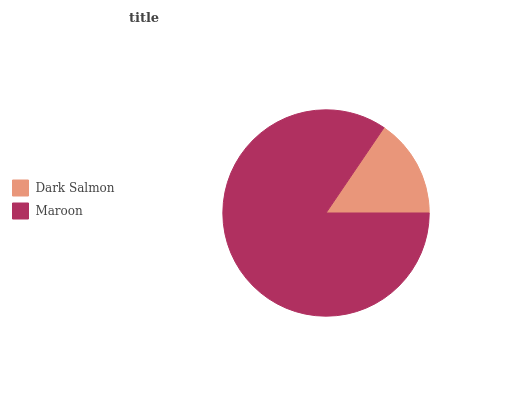Is Dark Salmon the minimum?
Answer yes or no. Yes. Is Maroon the maximum?
Answer yes or no. Yes. Is Maroon the minimum?
Answer yes or no. No. Is Maroon greater than Dark Salmon?
Answer yes or no. Yes. Is Dark Salmon less than Maroon?
Answer yes or no. Yes. Is Dark Salmon greater than Maroon?
Answer yes or no. No. Is Maroon less than Dark Salmon?
Answer yes or no. No. Is Maroon the high median?
Answer yes or no. Yes. Is Dark Salmon the low median?
Answer yes or no. Yes. Is Dark Salmon the high median?
Answer yes or no. No. Is Maroon the low median?
Answer yes or no. No. 